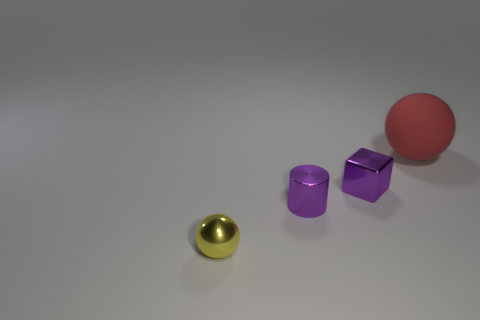There is a block that is the same size as the yellow thing; what material is it? metal 